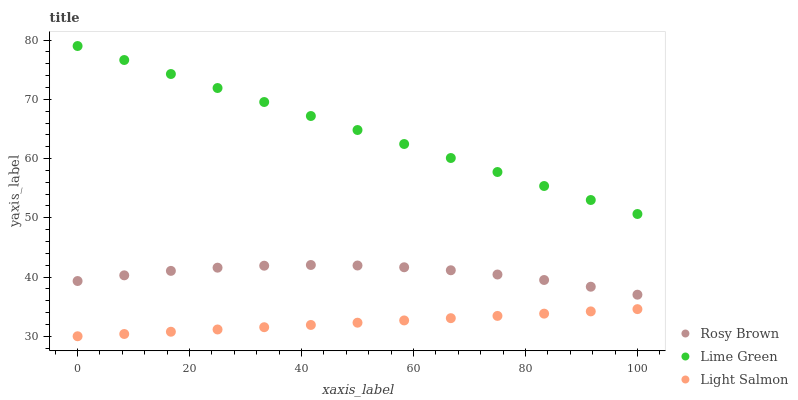Does Light Salmon have the minimum area under the curve?
Answer yes or no. Yes. Does Lime Green have the maximum area under the curve?
Answer yes or no. Yes. Does Rosy Brown have the minimum area under the curve?
Answer yes or no. No. Does Rosy Brown have the maximum area under the curve?
Answer yes or no. No. Is Light Salmon the smoothest?
Answer yes or no. Yes. Is Rosy Brown the roughest?
Answer yes or no. Yes. Is Lime Green the smoothest?
Answer yes or no. No. Is Lime Green the roughest?
Answer yes or no. No. Does Light Salmon have the lowest value?
Answer yes or no. Yes. Does Rosy Brown have the lowest value?
Answer yes or no. No. Does Lime Green have the highest value?
Answer yes or no. Yes. Does Rosy Brown have the highest value?
Answer yes or no. No. Is Light Salmon less than Lime Green?
Answer yes or no. Yes. Is Lime Green greater than Rosy Brown?
Answer yes or no. Yes. Does Light Salmon intersect Lime Green?
Answer yes or no. No. 